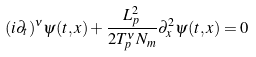Convert formula to latex. <formula><loc_0><loc_0><loc_500><loc_500>( i { \partial } _ { t } ) ^ { \nu } \psi ( t , x ) + \frac { L _ { p } ^ { 2 } } { 2 T _ { p } ^ { \nu } N _ { m } } { \partial } _ { x } ^ { 2 } \psi ( t , x ) = 0</formula> 